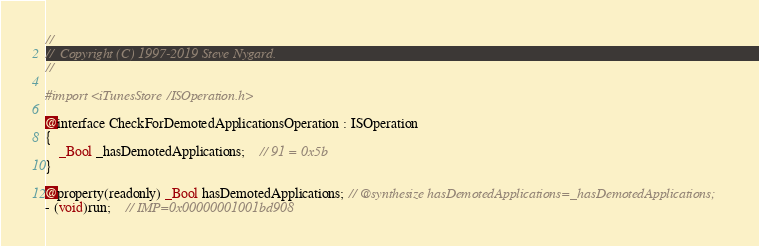<code> <loc_0><loc_0><loc_500><loc_500><_C_>//
//  Copyright (C) 1997-2019 Steve Nygard.
//

#import <iTunesStore/ISOperation.h>

@interface CheckForDemotedApplicationsOperation : ISOperation
{
    _Bool _hasDemotedApplications;	// 91 = 0x5b
}

@property(readonly) _Bool hasDemotedApplications; // @synthesize hasDemotedApplications=_hasDemotedApplications;
- (void)run;	// IMP=0x00000001001bd908</code> 